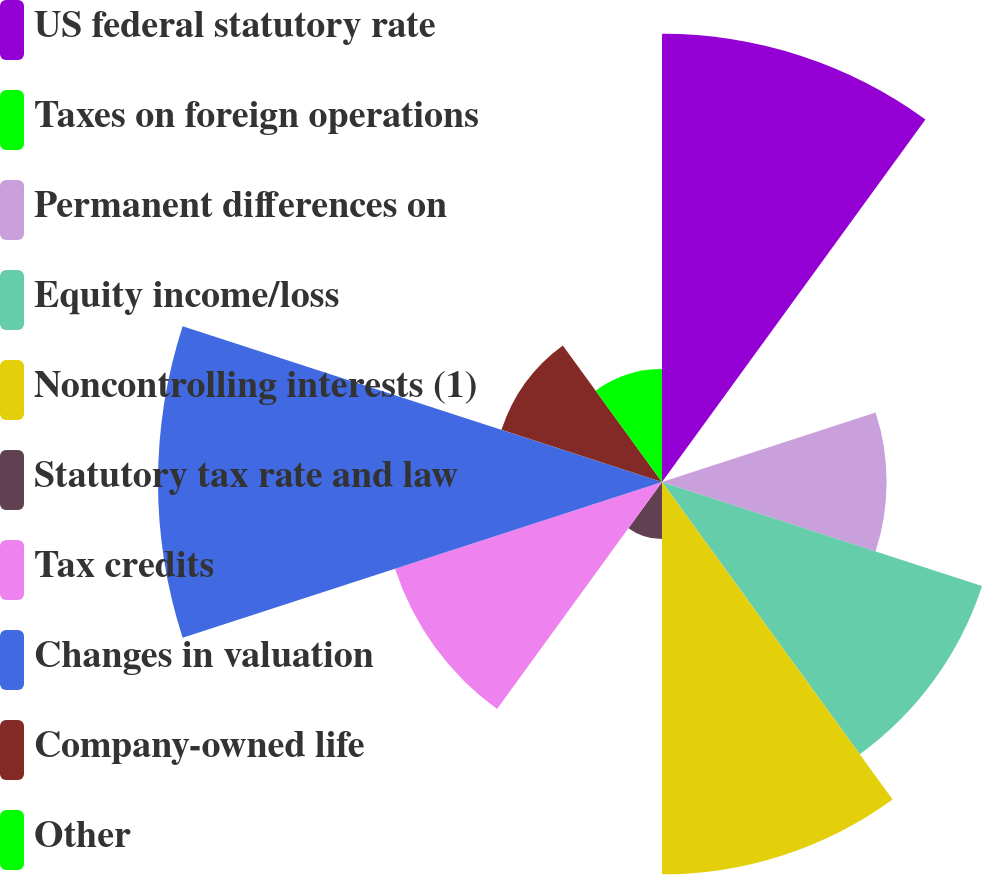Convert chart to OTSL. <chart><loc_0><loc_0><loc_500><loc_500><pie_chart><fcel>US federal statutory rate<fcel>Taxes on foreign operations<fcel>Permanent differences on<fcel>Equity income/loss<fcel>Noncontrolling interests (1)<fcel>Statutory tax rate and law<fcel>Tax credits<fcel>Changes in valuation<fcel>Company-owned life<fcel>Other<nl><fcel>17.74%<fcel>0.05%<fcel>8.89%<fcel>13.32%<fcel>15.53%<fcel>2.26%<fcel>11.11%<fcel>19.95%<fcel>6.68%<fcel>4.47%<nl></chart> 